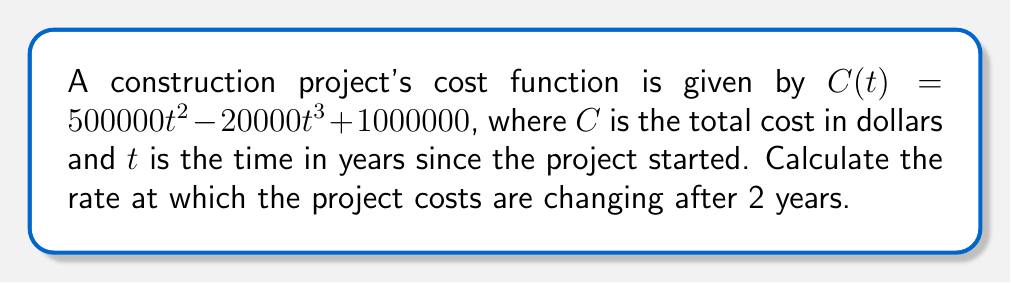Solve this math problem. To find the rate of change in construction costs over time, we need to calculate the derivative of the cost function $C(t)$ and evaluate it at $t = 2$ years.

Step 1: Find the derivative of $C(t)$
$$\frac{d}{dt}C(t) = \frac{d}{dt}(500000t^2 - 20000t^3 + 1000000)$$
$$C'(t) = 1000000t - 60000t^2$$

Step 2: Evaluate $C'(t)$ at $t = 2$
$$C'(2) = 1000000(2) - 60000(2^2)$$
$$C'(2) = 2000000 - 240000$$
$$C'(2) = 1760000$$

The rate of change is positive, indicating that costs are increasing at this point in time.
Answer: $1,760,000 per year 